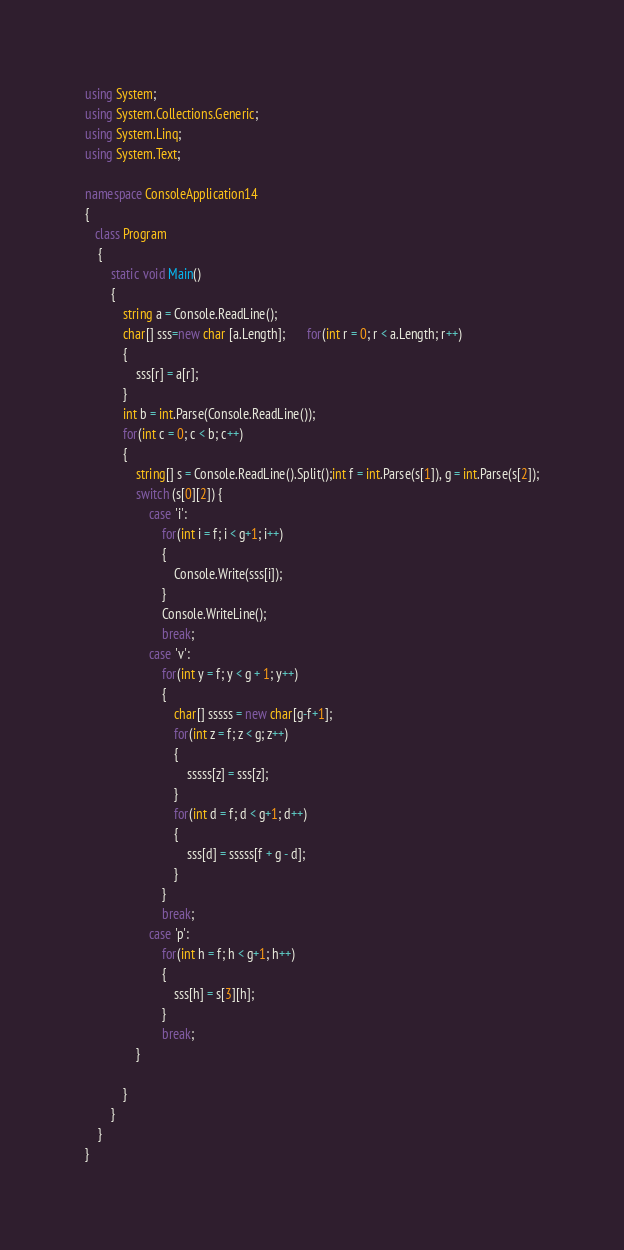Convert code to text. <code><loc_0><loc_0><loc_500><loc_500><_C#_>using System;
using System.Collections.Generic;
using System.Linq;
using System.Text;

namespace ConsoleApplication14
{
   class Program
    {
        static void Main()
        {
            string a = Console.ReadLine();
            char[] sss=new char [a.Length];       for(int r = 0; r < a.Length; r++)
            {
                sss[r] = a[r];
            }
            int b = int.Parse(Console.ReadLine());
            for(int c = 0; c < b; c++)
            {
                string[] s = Console.ReadLine().Split();int f = int.Parse(s[1]), g = int.Parse(s[2]);
                switch (s[0][2]) {
                    case 'i':
                        for(int i = f; i < g+1; i++)
                        {
                            Console.Write(sss[i]);
                        }
                        Console.WriteLine();
                        break;
                    case 'v':
                        for(int y = f; y < g + 1; y++)
                        {
                            char[] sssss = new char[g-f+1];
                            for(int z = f; z < g; z++)
                            {
                                sssss[z] = sss[z];
                            }
                            for(int d = f; d < g+1; d++)
                            {
                                sss[d] = sssss[f + g - d];
                            }
                        }
                        break;
                    case 'p':
                        for(int h = f; h < g+1; h++)
                        {
                            sss[h] = s[3][h];
                        }
                        break;
                }

            }
        }
    }
}</code> 